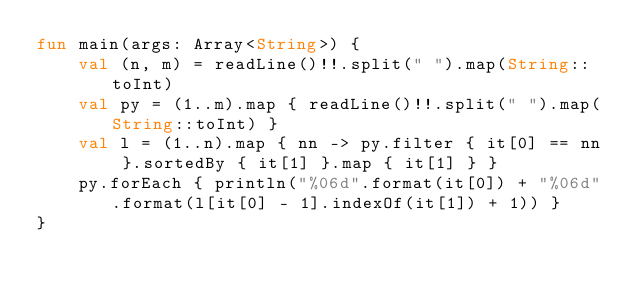<code> <loc_0><loc_0><loc_500><loc_500><_Kotlin_>fun main(args: Array<String>) {
    val (n, m) = readLine()!!.split(" ").map(String::toInt)
    val py = (1..m).map { readLine()!!.split(" ").map(String::toInt) }
    val l = (1..n).map { nn -> py.filter { it[0] == nn }.sortedBy { it[1] }.map { it[1] } }
    py.forEach { println("%06d".format(it[0]) + "%06d".format(l[it[0] - 1].indexOf(it[1]) + 1)) }
}</code> 